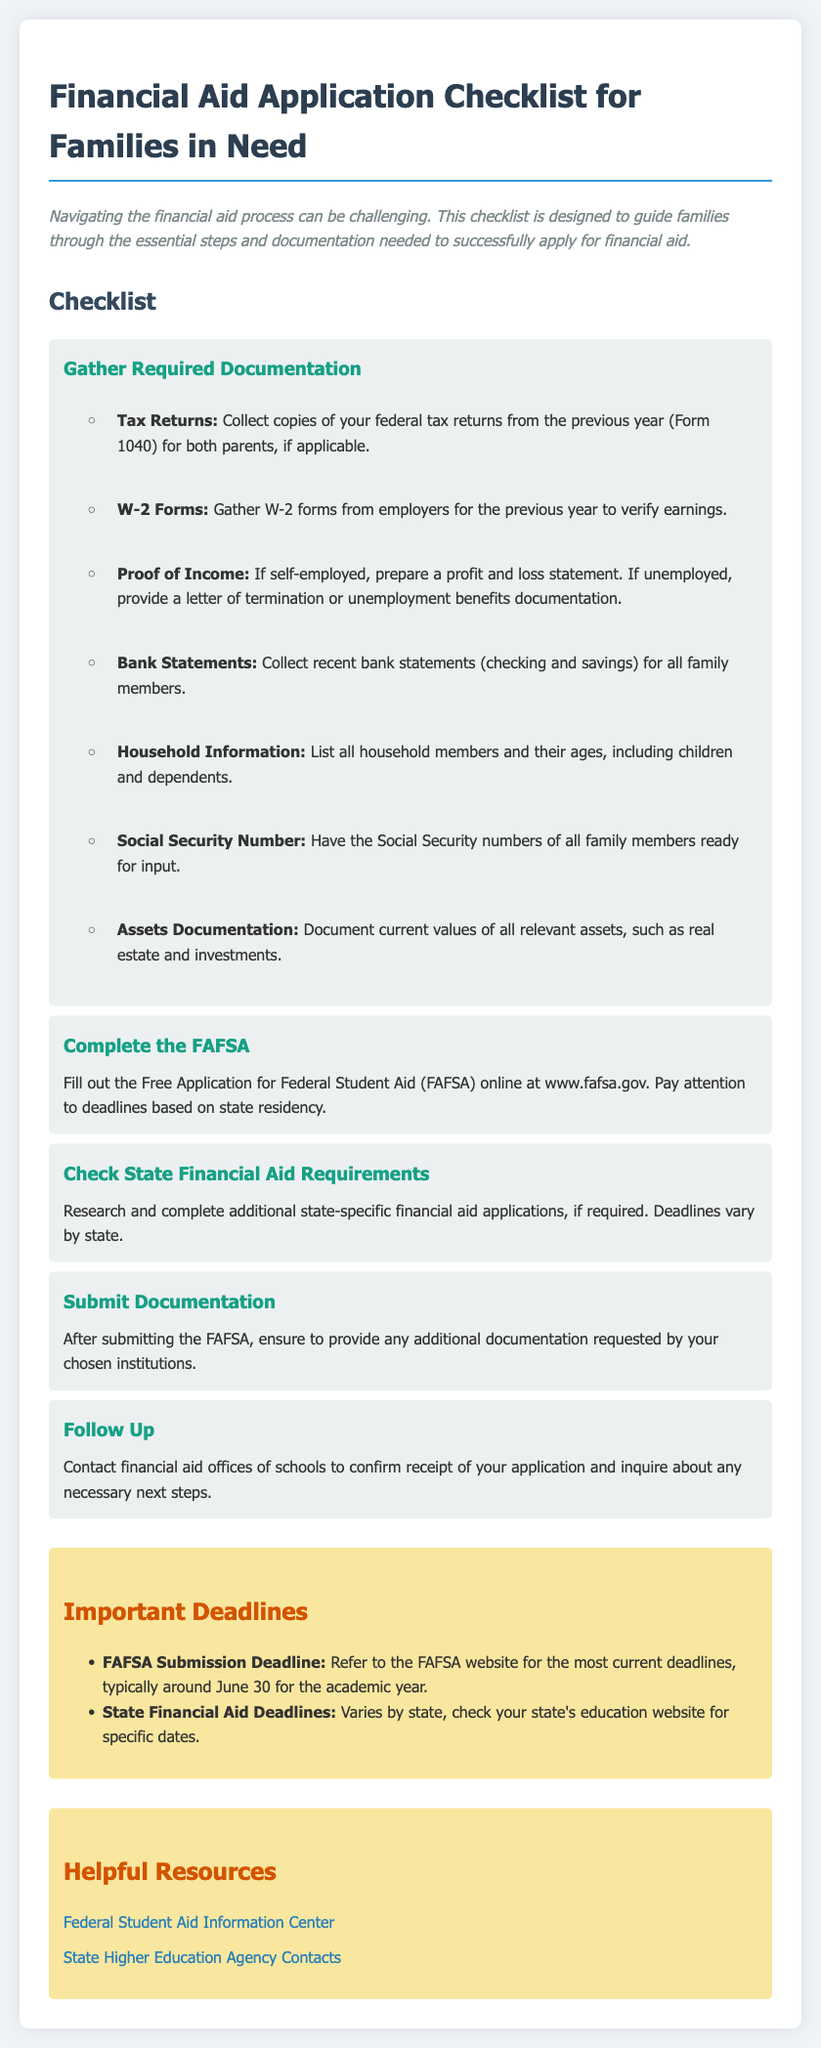What is the URL for FAFSA? The document states that one should fill out the FAFSA online at www.fafsa.gov.
Answer: www.fafsa.gov What documentation is required for proof of income if self-employed? The checklist specifies to prepare a profit and loss statement if self-employed.
Answer: Profit and loss statement What is the deadline for FAFSA submission? The document states that typically the FAFSA submission deadline is around June 30 for the academic year.
Answer: June 30 What should you do after submitting the FAFSA? The checklist advises to provide any additional documentation requested by chosen institutions after submitting the FAFSA.
Answer: Provide additional documentation Where can you find state financial aid requirements? The document suggests checking your state's education website for specific dates on state financial aid requirements.
Answer: State's education website What type of organization's contact information can be found in the helpful resources? The document lists state higher education agency contacts in the helpful resources section.
Answer: State higher education agency contacts How many steps are included in the checklist? There are five distinct steps mentioned in the checklist for applying for financial aid.
Answer: Five What is one item listed under 'Gather Required Documentation'? The checklist includes "collect copies of your federal tax returns from the previous year (Form 1040)" as one required document.
Answer: Tax Returns What should you do to confirm receipt of your application? The document states you should contact financial aid offices of schools to confirm receipt of your application.
Answer: Contact financial aid offices 